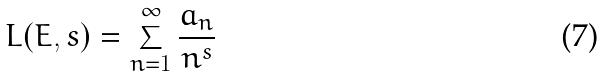Convert formula to latex. <formula><loc_0><loc_0><loc_500><loc_500>L ( E , s ) = \sum _ { n = 1 } ^ { \infty } \frac { a _ { n } } { n ^ { s } }</formula> 